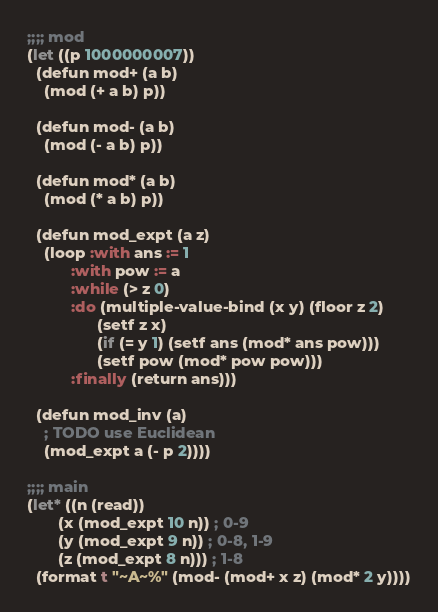Convert code to text. <code><loc_0><loc_0><loc_500><loc_500><_Lisp_>;;;; mod
(let ((p 1000000007))
  (defun mod+ (a b)
    (mod (+ a b) p))

  (defun mod- (a b)
    (mod (- a b) p))

  (defun mod* (a b)
    (mod (* a b) p))

  (defun mod_expt (a z)
    (loop :with ans := 1
          :with pow := a
          :while (> z 0)
          :do (multiple-value-bind (x y) (floor z 2)
                (setf z x)
                (if (= y 1) (setf ans (mod* ans pow)))
                (setf pow (mod* pow pow)))
          :finally (return ans)))

  (defun mod_inv (a)
    ; TODO use Euclidean
    (mod_expt a (- p 2))))

;;;; main
(let* ((n (read))
       (x (mod_expt 10 n)) ; 0-9
       (y (mod_expt 9 n)) ; 0-8, 1-9
       (z (mod_expt 8 n))) ; 1-8
  (format t "~A~%" (mod- (mod+ x z) (mod* 2 y))))
</code> 